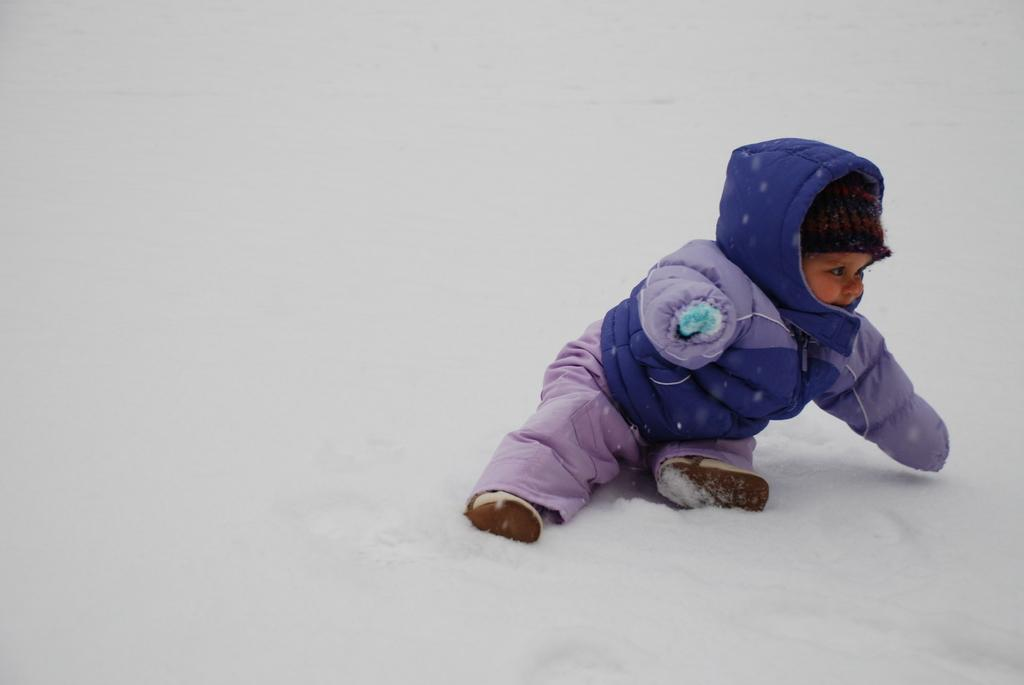What is the main subject of the image? There is a baby in the image. What is the baby wearing? The baby is wearing a coat. Can you describe the coat's color combination? The coat has a violet and gray color combination. Where is the baby sitting? The baby is sitting on a snow surface. What is the color of the ground in the image? The ground is white in color. How would you describe the background of the image? The background of the image is white. What type of beast can be seen interacting with the baby in the image? There is no beast present in the image; it only features a baby sitting on a snow surface. Can you identify the actor who is playing the role of the baby in the image? The image is a photograph, not a film or play, so there is no actor playing the role of the baby. 